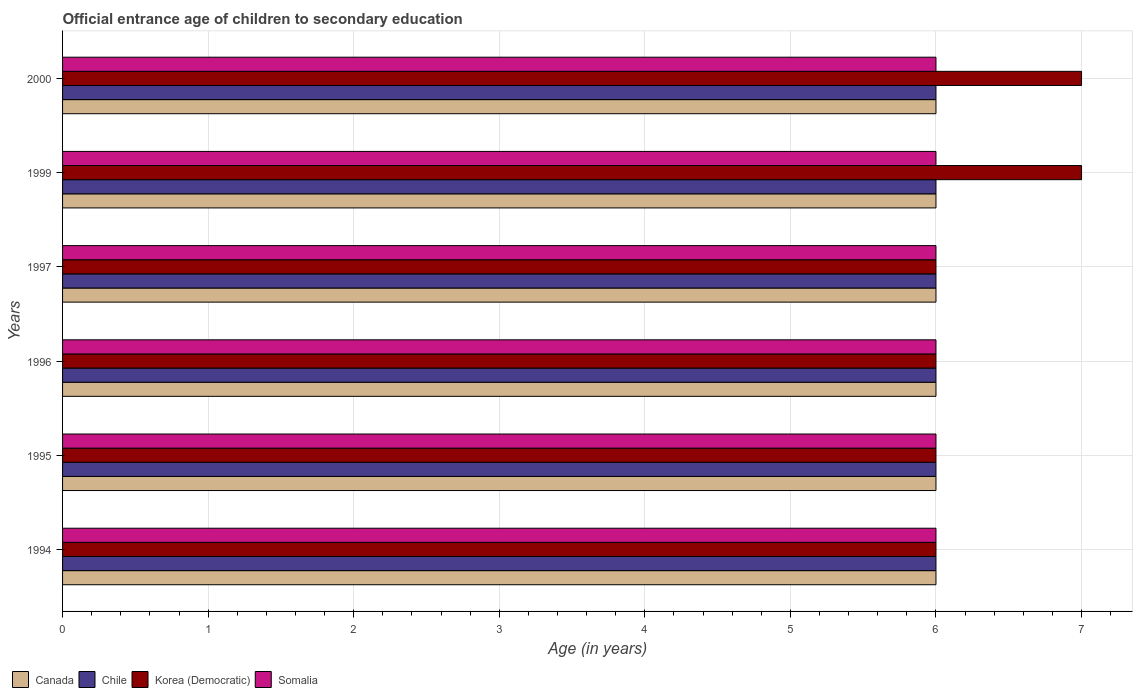How many groups of bars are there?
Provide a short and direct response. 6. Are the number of bars per tick equal to the number of legend labels?
Keep it short and to the point. Yes. Are the number of bars on each tick of the Y-axis equal?
Your answer should be compact. Yes. How many bars are there on the 6th tick from the top?
Offer a very short reply. 4. How many bars are there on the 3rd tick from the bottom?
Your answer should be compact. 4. What is the label of the 4th group of bars from the top?
Your answer should be compact. 1996. What is the secondary school starting age of children in Canada in 1996?
Keep it short and to the point. 6. Across all years, what is the minimum secondary school starting age of children in Somalia?
Keep it short and to the point. 6. In which year was the secondary school starting age of children in Canada maximum?
Your answer should be compact. 1994. What is the difference between the secondary school starting age of children in Somalia in 1994 and that in 1996?
Offer a terse response. 0. What is the difference between the secondary school starting age of children in Korea (Democratic) in 1995 and the secondary school starting age of children in Canada in 1999?
Offer a very short reply. 0. What is the average secondary school starting age of children in Somalia per year?
Your answer should be compact. 6. In how many years, is the secondary school starting age of children in Canada greater than 3.4 years?
Offer a very short reply. 6. What is the ratio of the secondary school starting age of children in Canada in 1994 to that in 1995?
Provide a succinct answer. 1. Is the difference between the secondary school starting age of children in Somalia in 1994 and 1999 greater than the difference between the secondary school starting age of children in Canada in 1994 and 1999?
Provide a short and direct response. No. What is the difference between the highest and the lowest secondary school starting age of children in Korea (Democratic)?
Offer a very short reply. 1. Is the sum of the secondary school starting age of children in Chile in 1996 and 2000 greater than the maximum secondary school starting age of children in Somalia across all years?
Provide a succinct answer. Yes. How many bars are there?
Your answer should be very brief. 24. Are all the bars in the graph horizontal?
Provide a succinct answer. Yes. What is the difference between two consecutive major ticks on the X-axis?
Offer a very short reply. 1. Are the values on the major ticks of X-axis written in scientific E-notation?
Your response must be concise. No. How many legend labels are there?
Your answer should be compact. 4. How are the legend labels stacked?
Your answer should be very brief. Horizontal. What is the title of the graph?
Provide a succinct answer. Official entrance age of children to secondary education. What is the label or title of the X-axis?
Ensure brevity in your answer.  Age (in years). What is the Age (in years) of Chile in 1994?
Your response must be concise. 6. What is the Age (in years) in Korea (Democratic) in 1994?
Offer a terse response. 6. What is the Age (in years) in Canada in 1995?
Keep it short and to the point. 6. What is the Age (in years) in Somalia in 1995?
Your answer should be very brief. 6. What is the Age (in years) of Canada in 1996?
Your answer should be very brief. 6. What is the Age (in years) in Chile in 1996?
Offer a very short reply. 6. What is the Age (in years) of Somalia in 1996?
Ensure brevity in your answer.  6. What is the Age (in years) in Canada in 1997?
Your response must be concise. 6. What is the Age (in years) of Chile in 1997?
Keep it short and to the point. 6. What is the Age (in years) in Somalia in 1997?
Keep it short and to the point. 6. What is the Age (in years) of Korea (Democratic) in 1999?
Your response must be concise. 7. What is the Age (in years) in Korea (Democratic) in 2000?
Provide a short and direct response. 7. Across all years, what is the maximum Age (in years) of Somalia?
Your answer should be compact. 6. Across all years, what is the minimum Age (in years) of Canada?
Offer a very short reply. 6. Across all years, what is the minimum Age (in years) of Korea (Democratic)?
Your answer should be very brief. 6. Across all years, what is the minimum Age (in years) in Somalia?
Provide a succinct answer. 6. What is the total Age (in years) of Canada in the graph?
Give a very brief answer. 36. What is the total Age (in years) in Chile in the graph?
Offer a terse response. 36. What is the total Age (in years) of Korea (Democratic) in the graph?
Your answer should be very brief. 38. What is the difference between the Age (in years) of Chile in 1994 and that in 1995?
Your answer should be compact. 0. What is the difference between the Age (in years) in Somalia in 1994 and that in 1995?
Keep it short and to the point. 0. What is the difference between the Age (in years) of Canada in 1994 and that in 1996?
Offer a terse response. 0. What is the difference between the Age (in years) of Korea (Democratic) in 1994 and that in 1996?
Ensure brevity in your answer.  0. What is the difference between the Age (in years) of Canada in 1994 and that in 1999?
Offer a very short reply. 0. What is the difference between the Age (in years) in Chile in 1994 and that in 1999?
Ensure brevity in your answer.  0. What is the difference between the Age (in years) of Korea (Democratic) in 1994 and that in 1999?
Your answer should be compact. -1. What is the difference between the Age (in years) of Somalia in 1994 and that in 1999?
Your response must be concise. 0. What is the difference between the Age (in years) of Canada in 1994 and that in 2000?
Ensure brevity in your answer.  0. What is the difference between the Age (in years) in Chile in 1994 and that in 2000?
Keep it short and to the point. 0. What is the difference between the Age (in years) of Korea (Democratic) in 1994 and that in 2000?
Your answer should be very brief. -1. What is the difference between the Age (in years) in Somalia in 1994 and that in 2000?
Keep it short and to the point. 0. What is the difference between the Age (in years) in Korea (Democratic) in 1995 and that in 1996?
Provide a succinct answer. 0. What is the difference between the Age (in years) of Somalia in 1995 and that in 1996?
Your answer should be very brief. 0. What is the difference between the Age (in years) in Canada in 1995 and that in 1997?
Offer a very short reply. 0. What is the difference between the Age (in years) of Chile in 1995 and that in 1997?
Provide a succinct answer. 0. What is the difference between the Age (in years) of Korea (Democratic) in 1995 and that in 1997?
Ensure brevity in your answer.  0. What is the difference between the Age (in years) of Somalia in 1995 and that in 1997?
Your answer should be very brief. 0. What is the difference between the Age (in years) of Canada in 1995 and that in 1999?
Provide a short and direct response. 0. What is the difference between the Age (in years) of Korea (Democratic) in 1995 and that in 1999?
Ensure brevity in your answer.  -1. What is the difference between the Age (in years) of Somalia in 1995 and that in 1999?
Keep it short and to the point. 0. What is the difference between the Age (in years) of Canada in 1995 and that in 2000?
Give a very brief answer. 0. What is the difference between the Age (in years) of Chile in 1995 and that in 2000?
Offer a very short reply. 0. What is the difference between the Age (in years) of Korea (Democratic) in 1995 and that in 2000?
Make the answer very short. -1. What is the difference between the Age (in years) of Korea (Democratic) in 1996 and that in 1997?
Your response must be concise. 0. What is the difference between the Age (in years) of Canada in 1996 and that in 1999?
Ensure brevity in your answer.  0. What is the difference between the Age (in years) in Chile in 1996 and that in 1999?
Make the answer very short. 0. What is the difference between the Age (in years) of Somalia in 1996 and that in 1999?
Your answer should be compact. 0. What is the difference between the Age (in years) in Chile in 1996 and that in 2000?
Offer a terse response. 0. What is the difference between the Age (in years) of Chile in 1997 and that in 1999?
Give a very brief answer. 0. What is the difference between the Age (in years) of Korea (Democratic) in 1997 and that in 1999?
Provide a succinct answer. -1. What is the difference between the Age (in years) of Somalia in 1997 and that in 2000?
Keep it short and to the point. 0. What is the difference between the Age (in years) of Canada in 1999 and that in 2000?
Your response must be concise. 0. What is the difference between the Age (in years) in Chile in 1999 and that in 2000?
Make the answer very short. 0. What is the difference between the Age (in years) in Korea (Democratic) in 1999 and that in 2000?
Give a very brief answer. 0. What is the difference between the Age (in years) of Somalia in 1999 and that in 2000?
Provide a succinct answer. 0. What is the difference between the Age (in years) in Canada in 1994 and the Age (in years) in Chile in 1995?
Give a very brief answer. 0. What is the difference between the Age (in years) in Canada in 1994 and the Age (in years) in Korea (Democratic) in 1995?
Make the answer very short. 0. What is the difference between the Age (in years) of Canada in 1994 and the Age (in years) of Somalia in 1995?
Provide a short and direct response. 0. What is the difference between the Age (in years) of Chile in 1994 and the Age (in years) of Korea (Democratic) in 1995?
Provide a short and direct response. 0. What is the difference between the Age (in years) in Korea (Democratic) in 1994 and the Age (in years) in Somalia in 1995?
Your answer should be compact. 0. What is the difference between the Age (in years) in Canada in 1994 and the Age (in years) in Korea (Democratic) in 1996?
Provide a succinct answer. 0. What is the difference between the Age (in years) in Chile in 1994 and the Age (in years) in Somalia in 1996?
Make the answer very short. 0. What is the difference between the Age (in years) in Canada in 1994 and the Age (in years) in Chile in 1997?
Your answer should be very brief. 0. What is the difference between the Age (in years) in Canada in 1994 and the Age (in years) in Somalia in 1997?
Keep it short and to the point. 0. What is the difference between the Age (in years) in Chile in 1994 and the Age (in years) in Korea (Democratic) in 1997?
Make the answer very short. 0. What is the difference between the Age (in years) of Chile in 1994 and the Age (in years) of Somalia in 1997?
Offer a terse response. 0. What is the difference between the Age (in years) in Canada in 1994 and the Age (in years) in Chile in 1999?
Ensure brevity in your answer.  0. What is the difference between the Age (in years) of Canada in 1994 and the Age (in years) of Korea (Democratic) in 1999?
Your response must be concise. -1. What is the difference between the Age (in years) of Canada in 1994 and the Age (in years) of Somalia in 1999?
Keep it short and to the point. 0. What is the difference between the Age (in years) of Chile in 1994 and the Age (in years) of Korea (Democratic) in 1999?
Offer a terse response. -1. What is the difference between the Age (in years) of Canada in 1994 and the Age (in years) of Chile in 2000?
Provide a short and direct response. 0. What is the difference between the Age (in years) in Canada in 1994 and the Age (in years) in Korea (Democratic) in 2000?
Keep it short and to the point. -1. What is the difference between the Age (in years) in Chile in 1994 and the Age (in years) in Korea (Democratic) in 2000?
Give a very brief answer. -1. What is the difference between the Age (in years) in Canada in 1995 and the Age (in years) in Korea (Democratic) in 1996?
Ensure brevity in your answer.  0. What is the difference between the Age (in years) of Chile in 1995 and the Age (in years) of Korea (Democratic) in 1996?
Provide a short and direct response. 0. What is the difference between the Age (in years) in Canada in 1995 and the Age (in years) in Korea (Democratic) in 1997?
Your answer should be very brief. 0. What is the difference between the Age (in years) of Canada in 1995 and the Age (in years) of Somalia in 1997?
Offer a terse response. 0. What is the difference between the Age (in years) of Chile in 1995 and the Age (in years) of Korea (Democratic) in 1997?
Provide a succinct answer. 0. What is the difference between the Age (in years) in Chile in 1995 and the Age (in years) in Somalia in 1997?
Keep it short and to the point. 0. What is the difference between the Age (in years) of Korea (Democratic) in 1995 and the Age (in years) of Somalia in 1997?
Make the answer very short. 0. What is the difference between the Age (in years) of Canada in 1995 and the Age (in years) of Chile in 1999?
Offer a terse response. 0. What is the difference between the Age (in years) in Canada in 1995 and the Age (in years) in Korea (Democratic) in 1999?
Ensure brevity in your answer.  -1. What is the difference between the Age (in years) in Korea (Democratic) in 1995 and the Age (in years) in Somalia in 1999?
Your response must be concise. 0. What is the difference between the Age (in years) of Canada in 1995 and the Age (in years) of Chile in 2000?
Your response must be concise. 0. What is the difference between the Age (in years) of Canada in 1996 and the Age (in years) of Chile in 1997?
Provide a succinct answer. 0. What is the difference between the Age (in years) of Canada in 1996 and the Age (in years) of Somalia in 1997?
Provide a short and direct response. 0. What is the difference between the Age (in years) of Chile in 1996 and the Age (in years) of Somalia in 1997?
Provide a succinct answer. 0. What is the difference between the Age (in years) in Canada in 1996 and the Age (in years) in Somalia in 1999?
Ensure brevity in your answer.  0. What is the difference between the Age (in years) of Chile in 1996 and the Age (in years) of Korea (Democratic) in 1999?
Make the answer very short. -1. What is the difference between the Age (in years) in Korea (Democratic) in 1996 and the Age (in years) in Somalia in 1999?
Provide a short and direct response. 0. What is the difference between the Age (in years) in Canada in 1996 and the Age (in years) in Chile in 2000?
Ensure brevity in your answer.  0. What is the difference between the Age (in years) in Canada in 1996 and the Age (in years) in Korea (Democratic) in 2000?
Keep it short and to the point. -1. What is the difference between the Age (in years) of Korea (Democratic) in 1996 and the Age (in years) of Somalia in 2000?
Make the answer very short. 0. What is the difference between the Age (in years) in Canada in 1997 and the Age (in years) in Chile in 1999?
Provide a short and direct response. 0. What is the difference between the Age (in years) of Chile in 1997 and the Age (in years) of Korea (Democratic) in 1999?
Provide a succinct answer. -1. What is the difference between the Age (in years) in Chile in 1997 and the Age (in years) in Somalia in 1999?
Offer a terse response. 0. What is the difference between the Age (in years) in Canada in 1997 and the Age (in years) in Chile in 2000?
Your response must be concise. 0. What is the difference between the Age (in years) of Canada in 1997 and the Age (in years) of Korea (Democratic) in 2000?
Your response must be concise. -1. What is the difference between the Age (in years) in Canada in 1999 and the Age (in years) in Chile in 2000?
Your answer should be very brief. 0. What is the difference between the Age (in years) in Canada in 1999 and the Age (in years) in Korea (Democratic) in 2000?
Your response must be concise. -1. What is the difference between the Age (in years) of Canada in 1999 and the Age (in years) of Somalia in 2000?
Provide a short and direct response. 0. What is the difference between the Age (in years) of Chile in 1999 and the Age (in years) of Somalia in 2000?
Your answer should be very brief. 0. What is the average Age (in years) of Canada per year?
Your response must be concise. 6. What is the average Age (in years) of Korea (Democratic) per year?
Provide a succinct answer. 6.33. What is the average Age (in years) in Somalia per year?
Your answer should be very brief. 6. In the year 1994, what is the difference between the Age (in years) of Canada and Age (in years) of Chile?
Your answer should be compact. 0. In the year 1994, what is the difference between the Age (in years) of Canada and Age (in years) of Korea (Democratic)?
Ensure brevity in your answer.  0. In the year 1994, what is the difference between the Age (in years) in Canada and Age (in years) in Somalia?
Provide a short and direct response. 0. In the year 1994, what is the difference between the Age (in years) of Chile and Age (in years) of Korea (Democratic)?
Offer a terse response. 0. In the year 1995, what is the difference between the Age (in years) in Canada and Age (in years) in Chile?
Your response must be concise. 0. In the year 1995, what is the difference between the Age (in years) in Canada and Age (in years) in Somalia?
Give a very brief answer. 0. In the year 1995, what is the difference between the Age (in years) in Korea (Democratic) and Age (in years) in Somalia?
Make the answer very short. 0. In the year 1996, what is the difference between the Age (in years) in Canada and Age (in years) in Chile?
Offer a very short reply. 0. In the year 1996, what is the difference between the Age (in years) in Canada and Age (in years) in Korea (Democratic)?
Offer a terse response. 0. In the year 1996, what is the difference between the Age (in years) in Canada and Age (in years) in Somalia?
Your answer should be very brief. 0. In the year 1996, what is the difference between the Age (in years) in Chile and Age (in years) in Korea (Democratic)?
Give a very brief answer. 0. In the year 1996, what is the difference between the Age (in years) of Chile and Age (in years) of Somalia?
Give a very brief answer. 0. In the year 1996, what is the difference between the Age (in years) in Korea (Democratic) and Age (in years) in Somalia?
Give a very brief answer. 0. In the year 1997, what is the difference between the Age (in years) of Canada and Age (in years) of Korea (Democratic)?
Your response must be concise. 0. In the year 1997, what is the difference between the Age (in years) of Chile and Age (in years) of Korea (Democratic)?
Your answer should be compact. 0. In the year 1999, what is the difference between the Age (in years) in Canada and Age (in years) in Chile?
Keep it short and to the point. 0. In the year 2000, what is the difference between the Age (in years) in Canada and Age (in years) in Chile?
Provide a short and direct response. 0. In the year 2000, what is the difference between the Age (in years) in Canada and Age (in years) in Korea (Democratic)?
Give a very brief answer. -1. In the year 2000, what is the difference between the Age (in years) of Canada and Age (in years) of Somalia?
Give a very brief answer. 0. In the year 2000, what is the difference between the Age (in years) of Chile and Age (in years) of Korea (Democratic)?
Offer a terse response. -1. In the year 2000, what is the difference between the Age (in years) in Korea (Democratic) and Age (in years) in Somalia?
Ensure brevity in your answer.  1. What is the ratio of the Age (in years) of Somalia in 1994 to that in 1995?
Your response must be concise. 1. What is the ratio of the Age (in years) of Canada in 1994 to that in 1996?
Your response must be concise. 1. What is the ratio of the Age (in years) of Chile in 1994 to that in 1996?
Provide a succinct answer. 1. What is the ratio of the Age (in years) in Somalia in 1994 to that in 1996?
Give a very brief answer. 1. What is the ratio of the Age (in years) in Chile in 1994 to that in 1997?
Offer a very short reply. 1. What is the ratio of the Age (in years) of Korea (Democratic) in 1994 to that in 1997?
Provide a succinct answer. 1. What is the ratio of the Age (in years) of Somalia in 1994 to that in 1997?
Your answer should be very brief. 1. What is the ratio of the Age (in years) of Chile in 1994 to that in 1999?
Provide a succinct answer. 1. What is the ratio of the Age (in years) of Canada in 1994 to that in 2000?
Ensure brevity in your answer.  1. What is the ratio of the Age (in years) of Chile in 1994 to that in 2000?
Keep it short and to the point. 1. What is the ratio of the Age (in years) in Canada in 1995 to that in 1996?
Your response must be concise. 1. What is the ratio of the Age (in years) in Korea (Democratic) in 1995 to that in 1996?
Give a very brief answer. 1. What is the ratio of the Age (in years) in Somalia in 1995 to that in 1996?
Your answer should be compact. 1. What is the ratio of the Age (in years) in Chile in 1995 to that in 1997?
Give a very brief answer. 1. What is the ratio of the Age (in years) of Korea (Democratic) in 1995 to that in 1997?
Your answer should be very brief. 1. What is the ratio of the Age (in years) of Somalia in 1995 to that in 1997?
Offer a very short reply. 1. What is the ratio of the Age (in years) in Chile in 1995 to that in 1999?
Give a very brief answer. 1. What is the ratio of the Age (in years) in Korea (Democratic) in 1995 to that in 1999?
Your answer should be compact. 0.86. What is the ratio of the Age (in years) in Somalia in 1995 to that in 1999?
Provide a succinct answer. 1. What is the ratio of the Age (in years) of Chile in 1995 to that in 2000?
Make the answer very short. 1. What is the ratio of the Age (in years) in Korea (Democratic) in 1995 to that in 2000?
Your answer should be compact. 0.86. What is the ratio of the Age (in years) of Canada in 1996 to that in 1997?
Make the answer very short. 1. What is the ratio of the Age (in years) of Chile in 1996 to that in 1997?
Provide a succinct answer. 1. What is the ratio of the Age (in years) in Canada in 1996 to that in 1999?
Provide a short and direct response. 1. What is the ratio of the Age (in years) of Chile in 1996 to that in 1999?
Ensure brevity in your answer.  1. What is the ratio of the Age (in years) in Somalia in 1996 to that in 1999?
Offer a very short reply. 1. What is the ratio of the Age (in years) of Korea (Democratic) in 1997 to that in 1999?
Ensure brevity in your answer.  0.86. What is the ratio of the Age (in years) in Korea (Democratic) in 1997 to that in 2000?
Ensure brevity in your answer.  0.86. What is the ratio of the Age (in years) in Korea (Democratic) in 1999 to that in 2000?
Offer a very short reply. 1. What is the difference between the highest and the lowest Age (in years) of Chile?
Ensure brevity in your answer.  0. What is the difference between the highest and the lowest Age (in years) in Korea (Democratic)?
Your response must be concise. 1. What is the difference between the highest and the lowest Age (in years) in Somalia?
Keep it short and to the point. 0. 